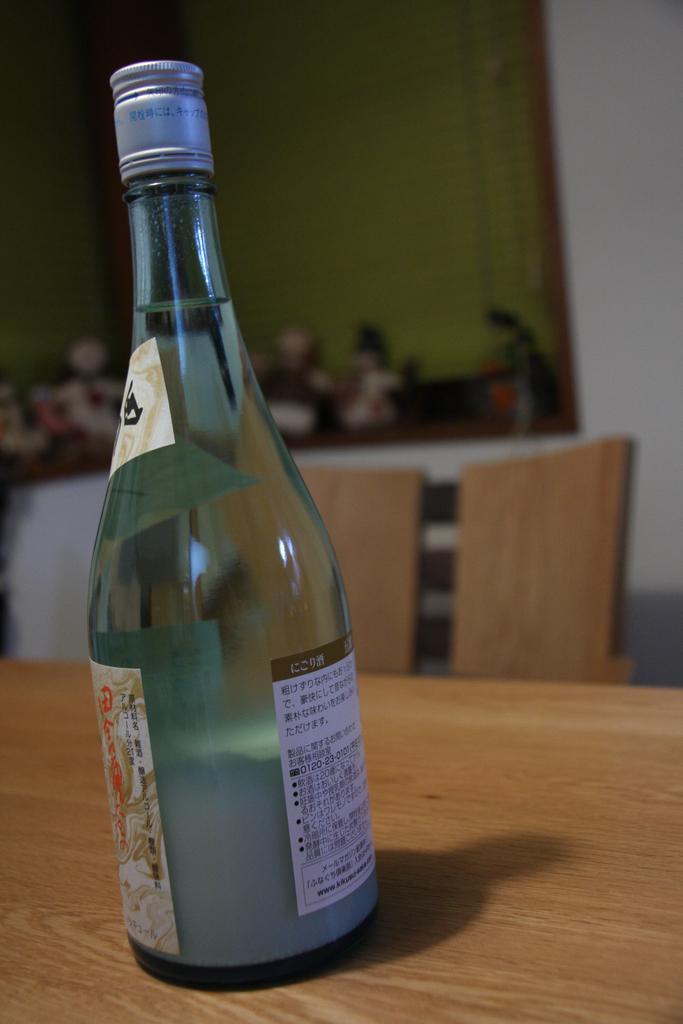In one or two sentences, can you explain what this image depicts? In this image I can see a wine bottle on the table. In the background the image is blur. 